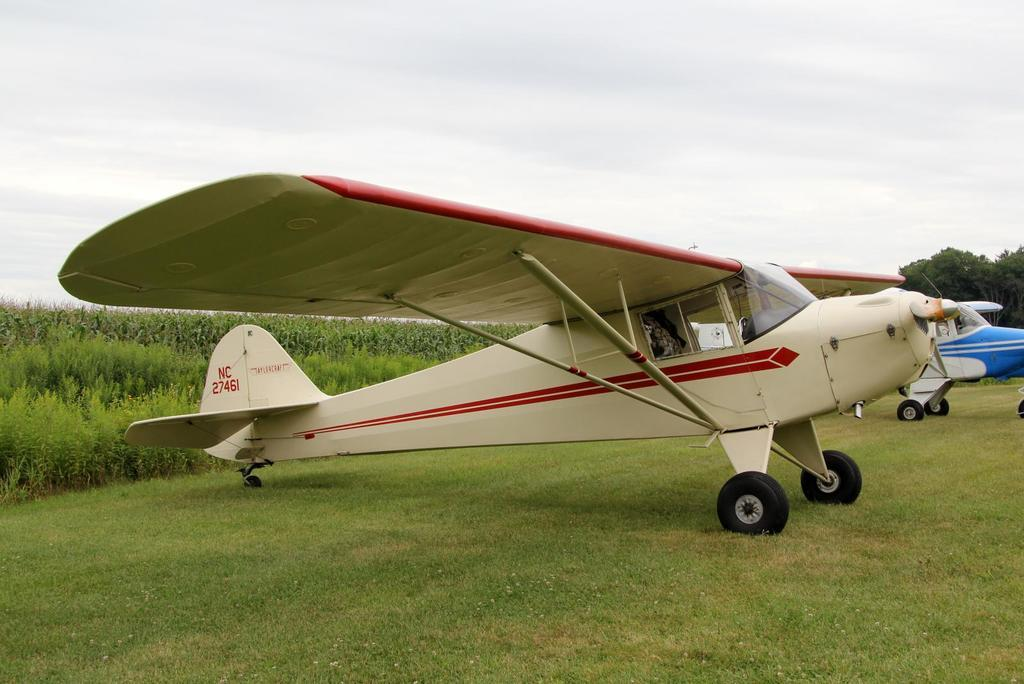What is the main subject of the image? The main subject of the image is aircraft. Where are the aircraft located? The aircraft are on a grassland. What can be seen in the background of the image? There is greenery in the background of the image. Where is the throne located in the image? There is no throne present in the image. What type of trip is being taken by the aircraft in the image? The image does not provide information about the purpose or destination of the aircraft, so it cannot be determined from the image. 